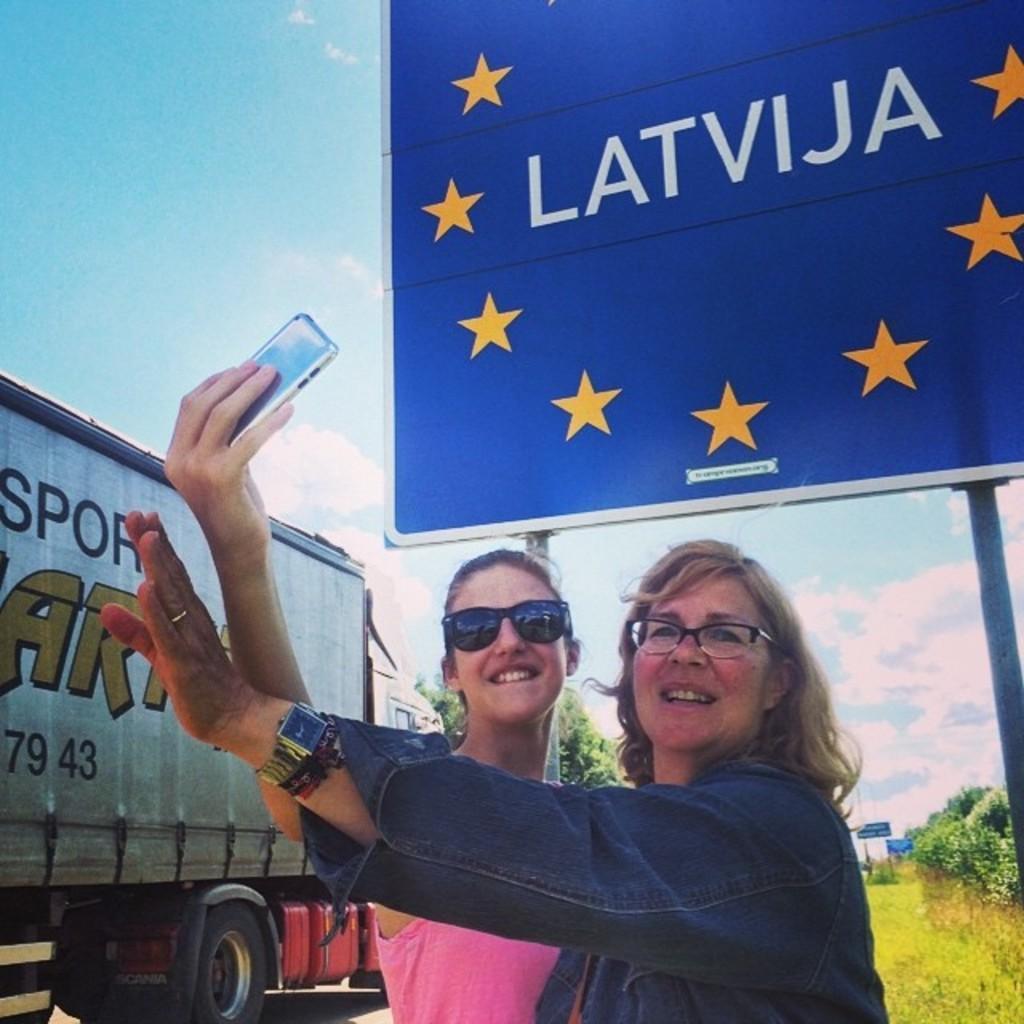In one or two sentences, can you explain what this image depicts? In this image i can see two women standing and laughing,the women here is holding a mobile,at the back ground i can see a banner,and a vehicle, a tree and a sky. 